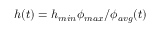<formula> <loc_0><loc_0><loc_500><loc_500>h ( t ) = h _ { \min } \phi _ { \max } / \phi _ { a v g } ( t )</formula> 